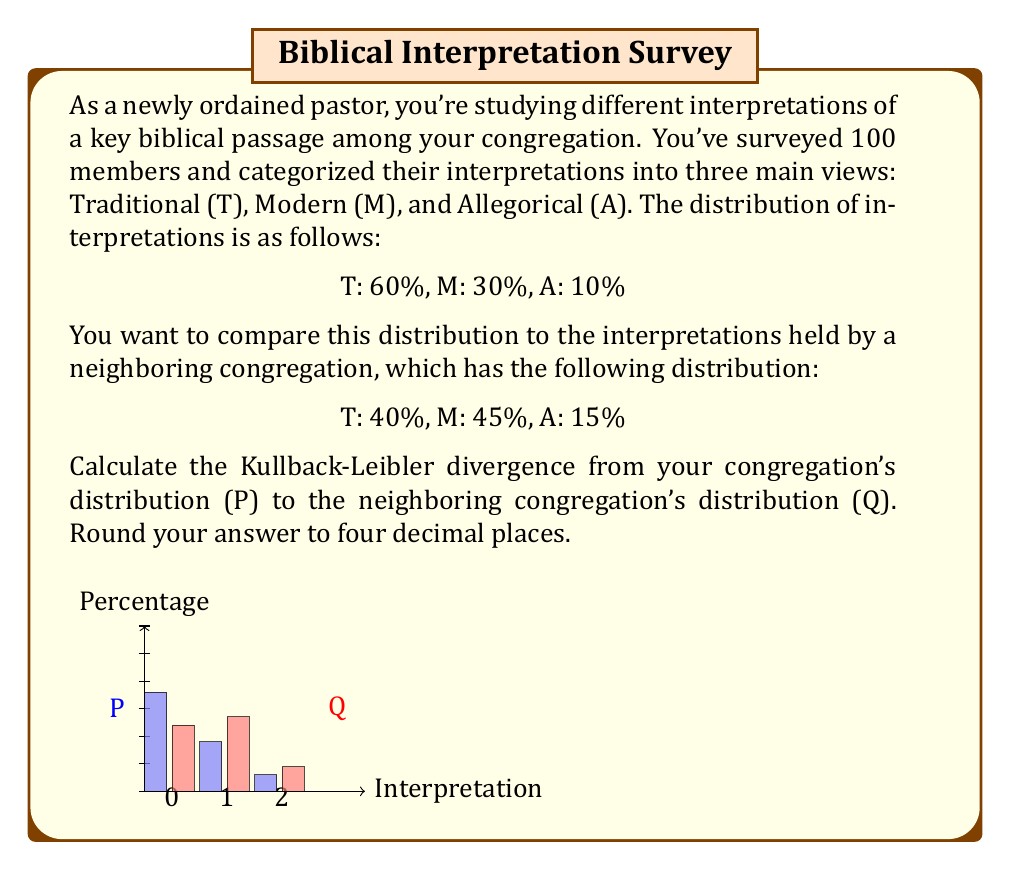Help me with this question. To solve this problem, we'll use the Kullback-Leibler divergence formula:

$$D_{KL}(P||Q) = \sum_{i} P(i) \log\left(\frac{P(i)}{Q(i)}\right)$$

Where $P(i)$ is the probability of event $i$ in distribution P, and $Q(i)$ is the probability of event $i$ in distribution Q.

Let's calculate each term:

1. For Traditional (T):
   $P(T) = 0.6$, $Q(T) = 0.4$
   $0.6 \log\left(\frac{0.6}{0.4}\right) = 0.6 \log(1.5) = 0.6 \cdot 0.4054651 = 0.2432791$

2. For Modern (M):
   $P(M) = 0.3$, $Q(M) = 0.45$
   $0.3 \log\left(\frac{0.3}{0.45}\right) = 0.3 \log(0.6666667) = 0.3 \cdot (-0.4054651) = -0.1216395$

3. For Allegorical (A):
   $P(A) = 0.1$, $Q(A) = 0.15$
   $0.1 \log\left(\frac{0.1}{0.15}\right) = 0.1 \log(0.6666667) = 0.1 \cdot (-0.4054651) = -0.0405465$

Now, sum these terms:

$$D_{KL}(P||Q) = 0.2432791 + (-0.1216395) + (-0.0405465) = 0.0810931$$

Rounding to four decimal places:

$$D_{KL}(P||Q) \approx 0.0811$$
Answer: 0.0811 